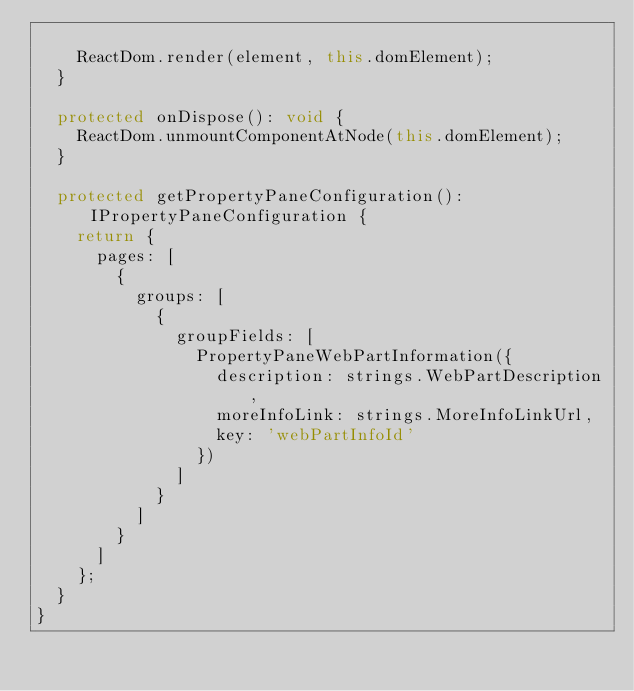<code> <loc_0><loc_0><loc_500><loc_500><_TypeScript_>
    ReactDom.render(element, this.domElement);
  }

  protected onDispose(): void {
    ReactDom.unmountComponentAtNode(this.domElement);
  }

  protected getPropertyPaneConfiguration(): IPropertyPaneConfiguration {
    return {
      pages: [
        {
          groups: [
            {
              groupFields: [
                PropertyPaneWebPartInformation({
                  description: strings.WebPartDescription,
                  moreInfoLink: strings.MoreInfoLinkUrl,
                  key: 'webPartInfoId'
                })
              ]
            }
          ]
        }
      ]
    };
  }
}
</code> 